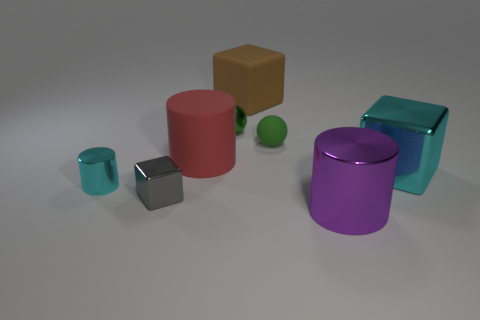Subtract all big cylinders. How many cylinders are left? 1 Add 2 big brown rubber things. How many objects exist? 10 Subtract all spheres. How many objects are left? 6 Subtract 1 purple cylinders. How many objects are left? 7 Subtract all small metallic objects. Subtract all cyan shiny cubes. How many objects are left? 4 Add 1 large purple things. How many large purple things are left? 2 Add 6 small cyan metallic objects. How many small cyan metallic objects exist? 7 